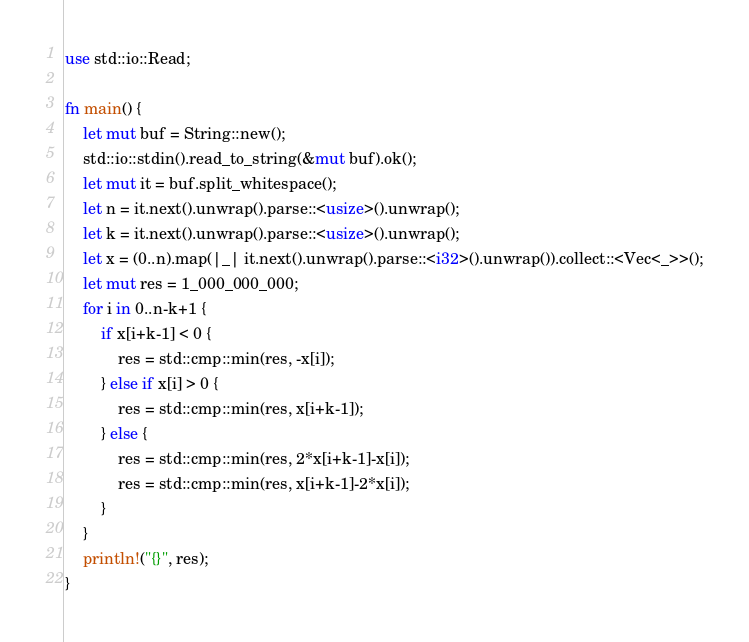Convert code to text. <code><loc_0><loc_0><loc_500><loc_500><_Rust_>use std::io::Read;

fn main() {
    let mut buf = String::new();
    std::io::stdin().read_to_string(&mut buf).ok();
    let mut it = buf.split_whitespace();
    let n = it.next().unwrap().parse::<usize>().unwrap();
    let k = it.next().unwrap().parse::<usize>().unwrap();
    let x = (0..n).map(|_| it.next().unwrap().parse::<i32>().unwrap()).collect::<Vec<_>>();
    let mut res = 1_000_000_000;
    for i in 0..n-k+1 {
        if x[i+k-1] < 0 {
            res = std::cmp::min(res, -x[i]);
        } else if x[i] > 0 {
            res = std::cmp::min(res, x[i+k-1]);
        } else {
            res = std::cmp::min(res, 2*x[i+k-1]-x[i]);
            res = std::cmp::min(res, x[i+k-1]-2*x[i]);
        }
    }
    println!("{}", res);
}
</code> 